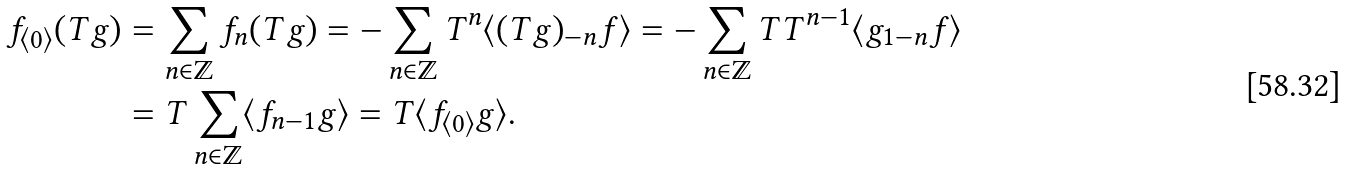Convert formula to latex. <formula><loc_0><loc_0><loc_500><loc_500>f _ { \langle 0 \rangle } ( T g ) & = \sum _ { n \in \mathbb { Z } } f _ { n } ( T g ) = - \sum _ { n \in \mathbb { Z } } T ^ { n } \langle ( T g ) _ { - n } f \rangle = - \sum _ { n \in \mathbb { Z } } T T ^ { n - 1 } \langle g _ { 1 - n } f \rangle \\ & = T \sum _ { n \in \mathbb { Z } } \langle f _ { n - 1 } g \rangle = T \langle f _ { \langle 0 \rangle } g \rangle .</formula> 